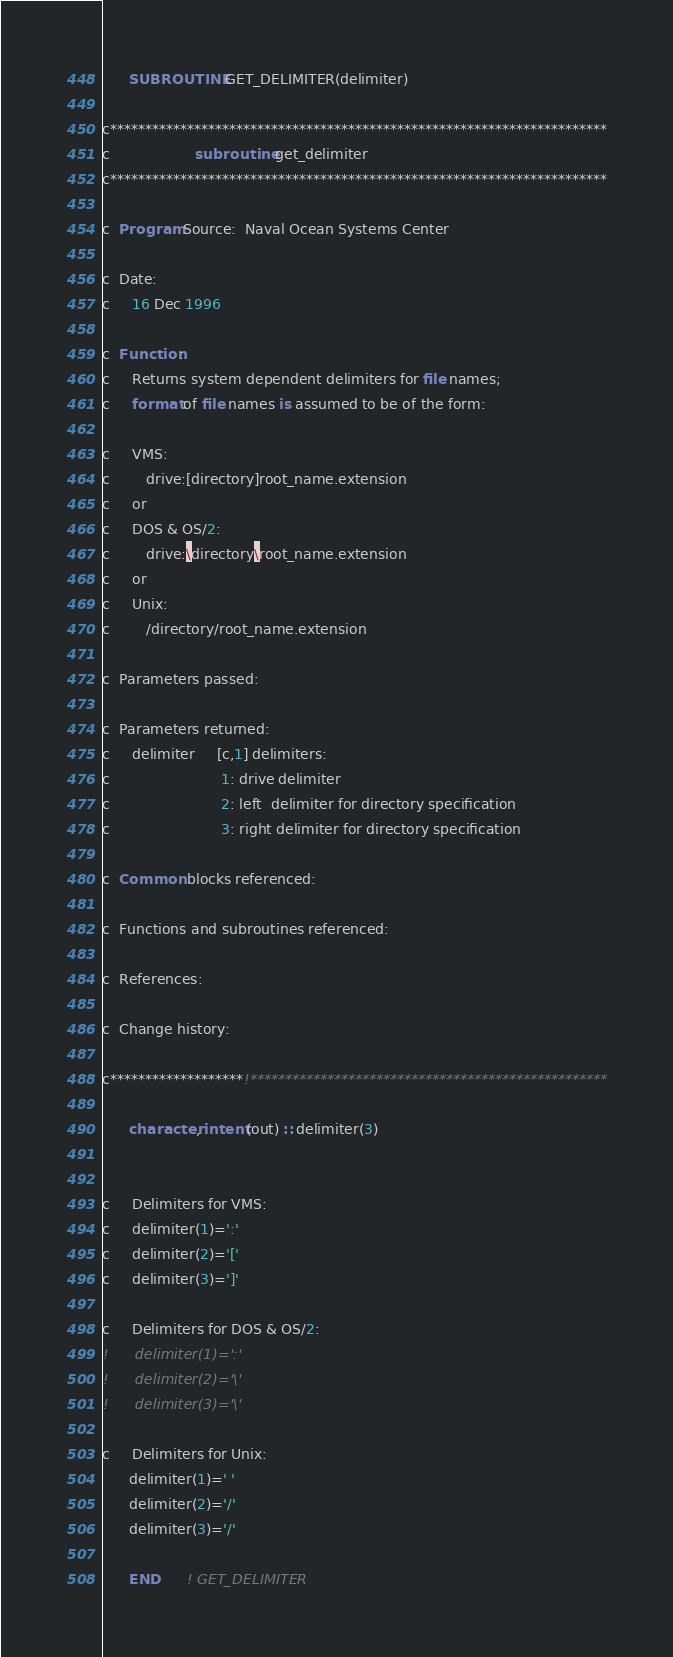<code> <loc_0><loc_0><loc_500><loc_500><_FORTRAN_>      SUBROUTINE GET_DELIMITER(delimiter)

c***********************************************************************
c                   subroutine get_delimiter
c***********************************************************************

c  Program Source:  Naval Ocean Systems Center

c  Date:
c     16 Dec 1996

c  Function:
c     Returns system dependent delimiters for file names;
c     format of file names is assumed to be of the form:

c     VMS:
c        drive:[directory]root_name.extension
c     or
c     DOS & OS/2:
c        drive:\directory\root_name.extension
c     or
c     Unix:
c        /directory/root_name.extension

c  Parameters passed:

c  Parameters returned:
c     delimiter     [c,1] delimiters:
c                         1: drive delimiter
c                         2: left  delimiter for directory specification
c                         3: right delimiter for directory specification

c  Common blocks referenced:

c  Functions and subroutines referenced:

c  References:

c  Change history:

c*******************!***************************************************

      character, intent(out) :: delimiter(3)


c     Delimiters for VMS:
c     delimiter(1)=':'
c     delimiter(2)='['
c     delimiter(3)=']'

c     Delimiters for DOS & OS/2:
!      delimiter(1)=':'
!      delimiter(2)='\'
!      delimiter(3)='\'

c     Delimiters for Unix:
      delimiter(1)=' '
      delimiter(2)='/'
      delimiter(3)='/'

      END      ! GET_DELIMITER
</code> 